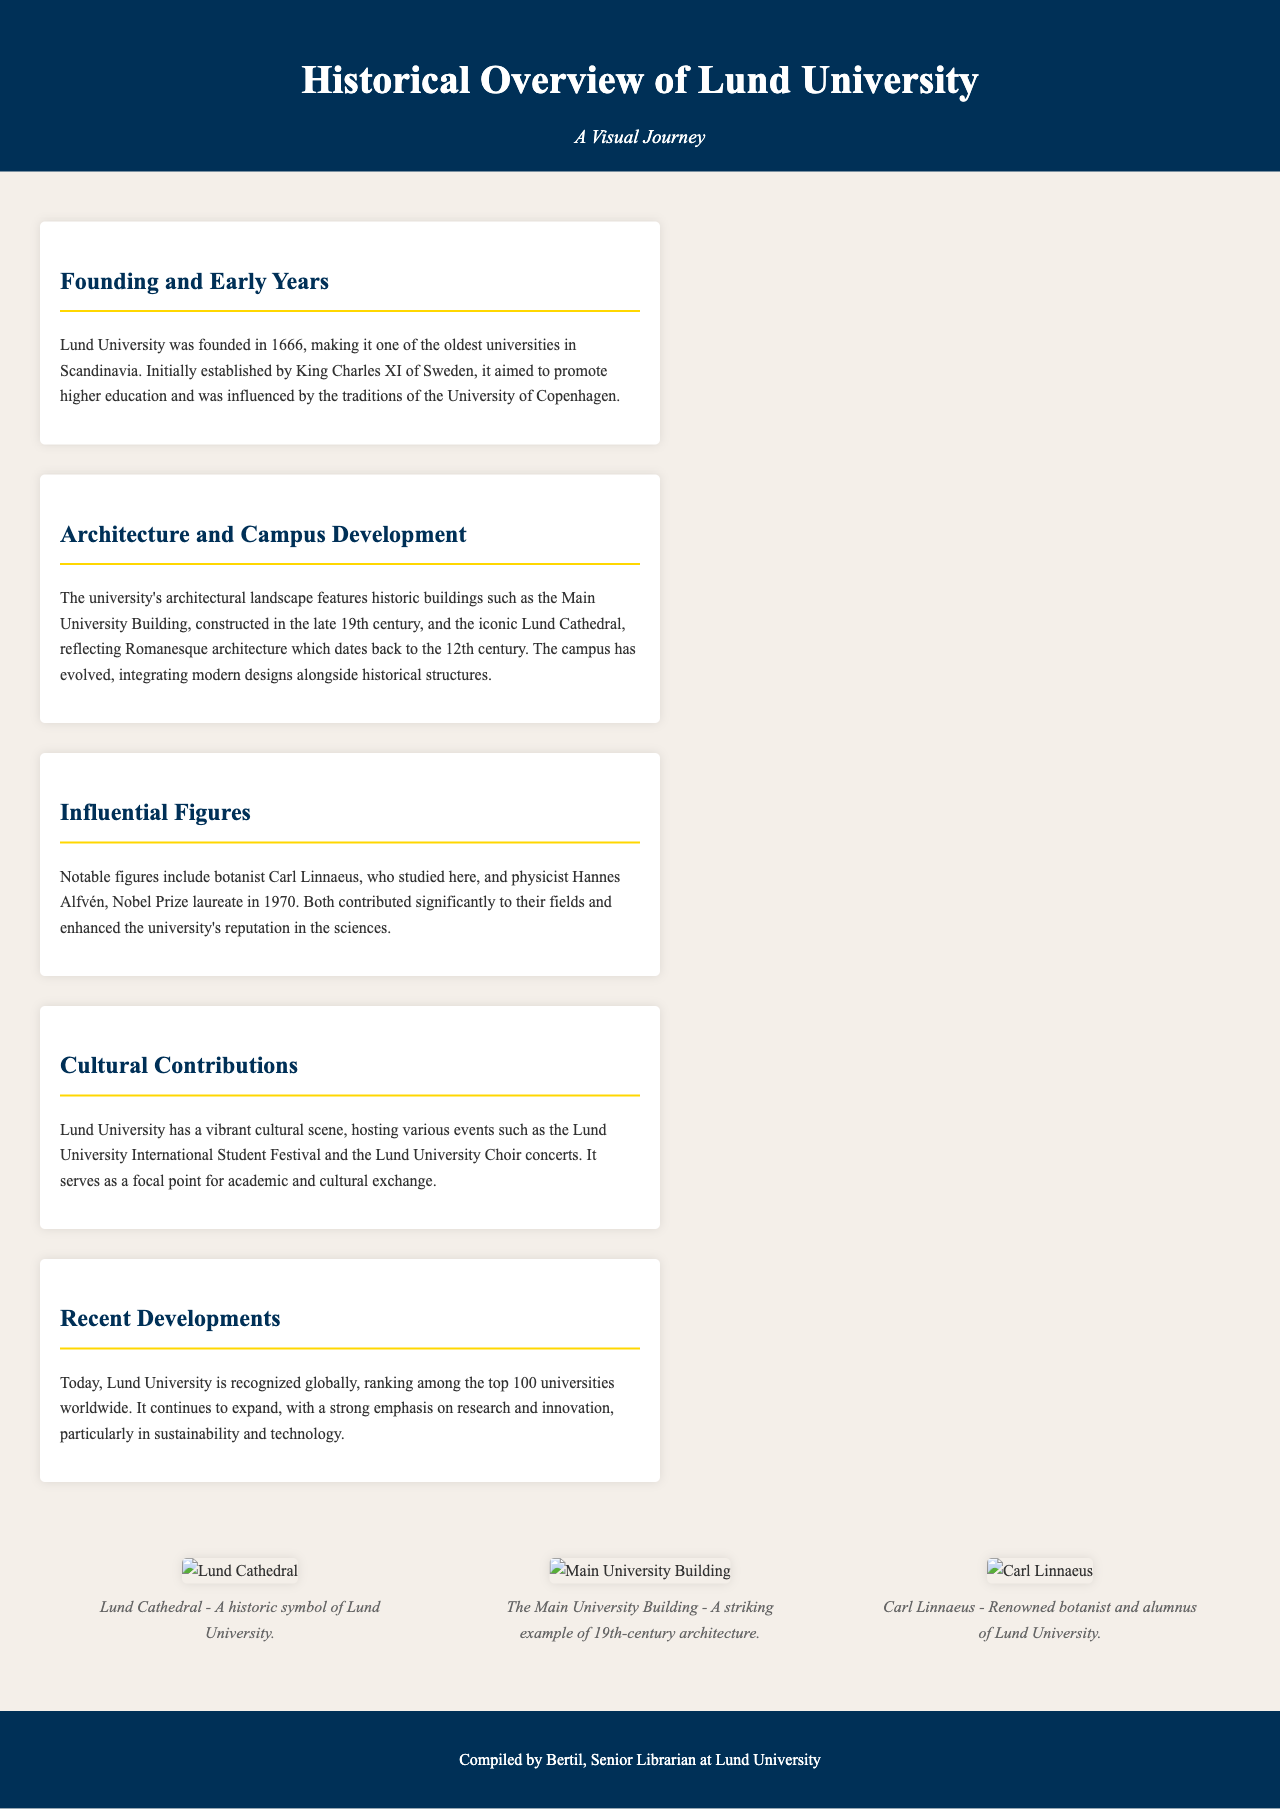What year was Lund University founded? The founding year of Lund University is explicitly mentioned in the document.
Answer: 1666 Who established Lund University? The document states that King Charles XI of Sweden established Lund University.
Answer: King Charles XI Which two notable figures are mentioned in the document? The document lists influential figures, specifically botanist Carl Linnaeus and physicist Hannes Alfvén.
Answer: Carl Linnaeus and Hannes Alfvén What architectural style is Lund Cathedral associated with? The document describes the architectural style of Lund Cathedral as Romanesque.
Answer: Romanesque What is Lund University's global ranking status today? The document states that Lund University is recognized globally and ranks among the top 100 universities worldwide.
Answer: Top 100 What major cultural event does Lund University host? The document mentions the Lund University International Student Festival as a key cultural event.
Answer: Lund University International Student Festival In which century was the Main University Building constructed? The document specifies that the Main University Building was constructed in the late 19th century.
Answer: 19th century What emphasis does Lund University place on its current developments? The document highlights the university's strong emphasis on research and innovation, particularly in sustainability and technology.
Answer: Research and innovation Which building is described as a striking example of 19th-century architecture? The document refers to the Main University Building as a notable example of 19th-century architecture.
Answer: The Main University Building 